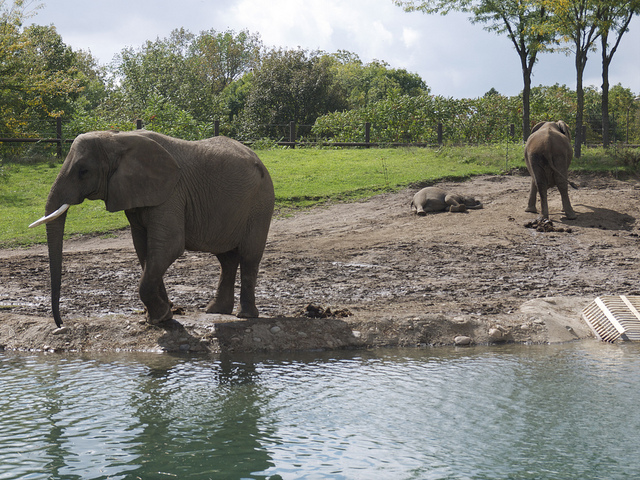What are the elephants doing in this picture? The elephant closest to the water appears to be either entering or leaving the pond, perhaps after cooling off. Meanwhile, the elephant in the background seems to be resting or sleeping on the ground, enjoying the warm sunlight. 